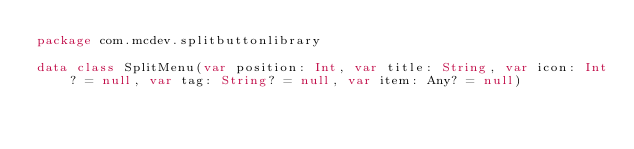<code> <loc_0><loc_0><loc_500><loc_500><_Kotlin_>package com.mcdev.splitbuttonlibrary

data class SplitMenu(var position: Int, var title: String, var icon: Int? = null, var tag: String? = null, var item: Any? = null)
</code> 